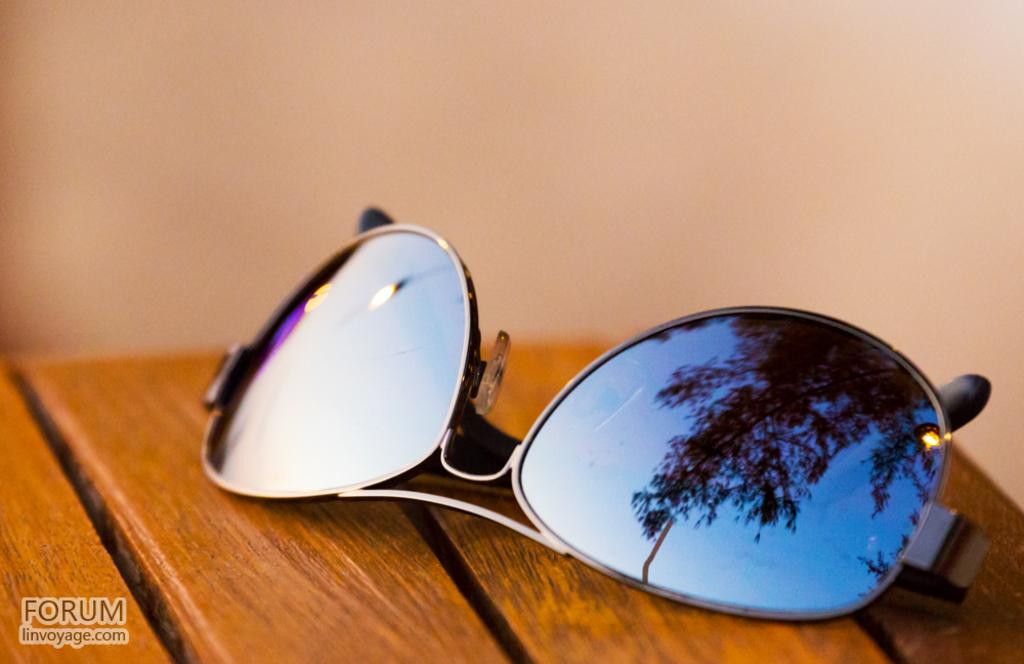What is located in the foreground of the picture? There is a table in the foreground of the picture. What objects can be seen on the table? Goggles are present on the table. Can you describe the background of the image? The background of the image is blurred. How many men are visible in the image, and what are they doing near the hydrant? There are no men or hydrants visible in the image; it only features a table with goggles on it and a blurred background. 